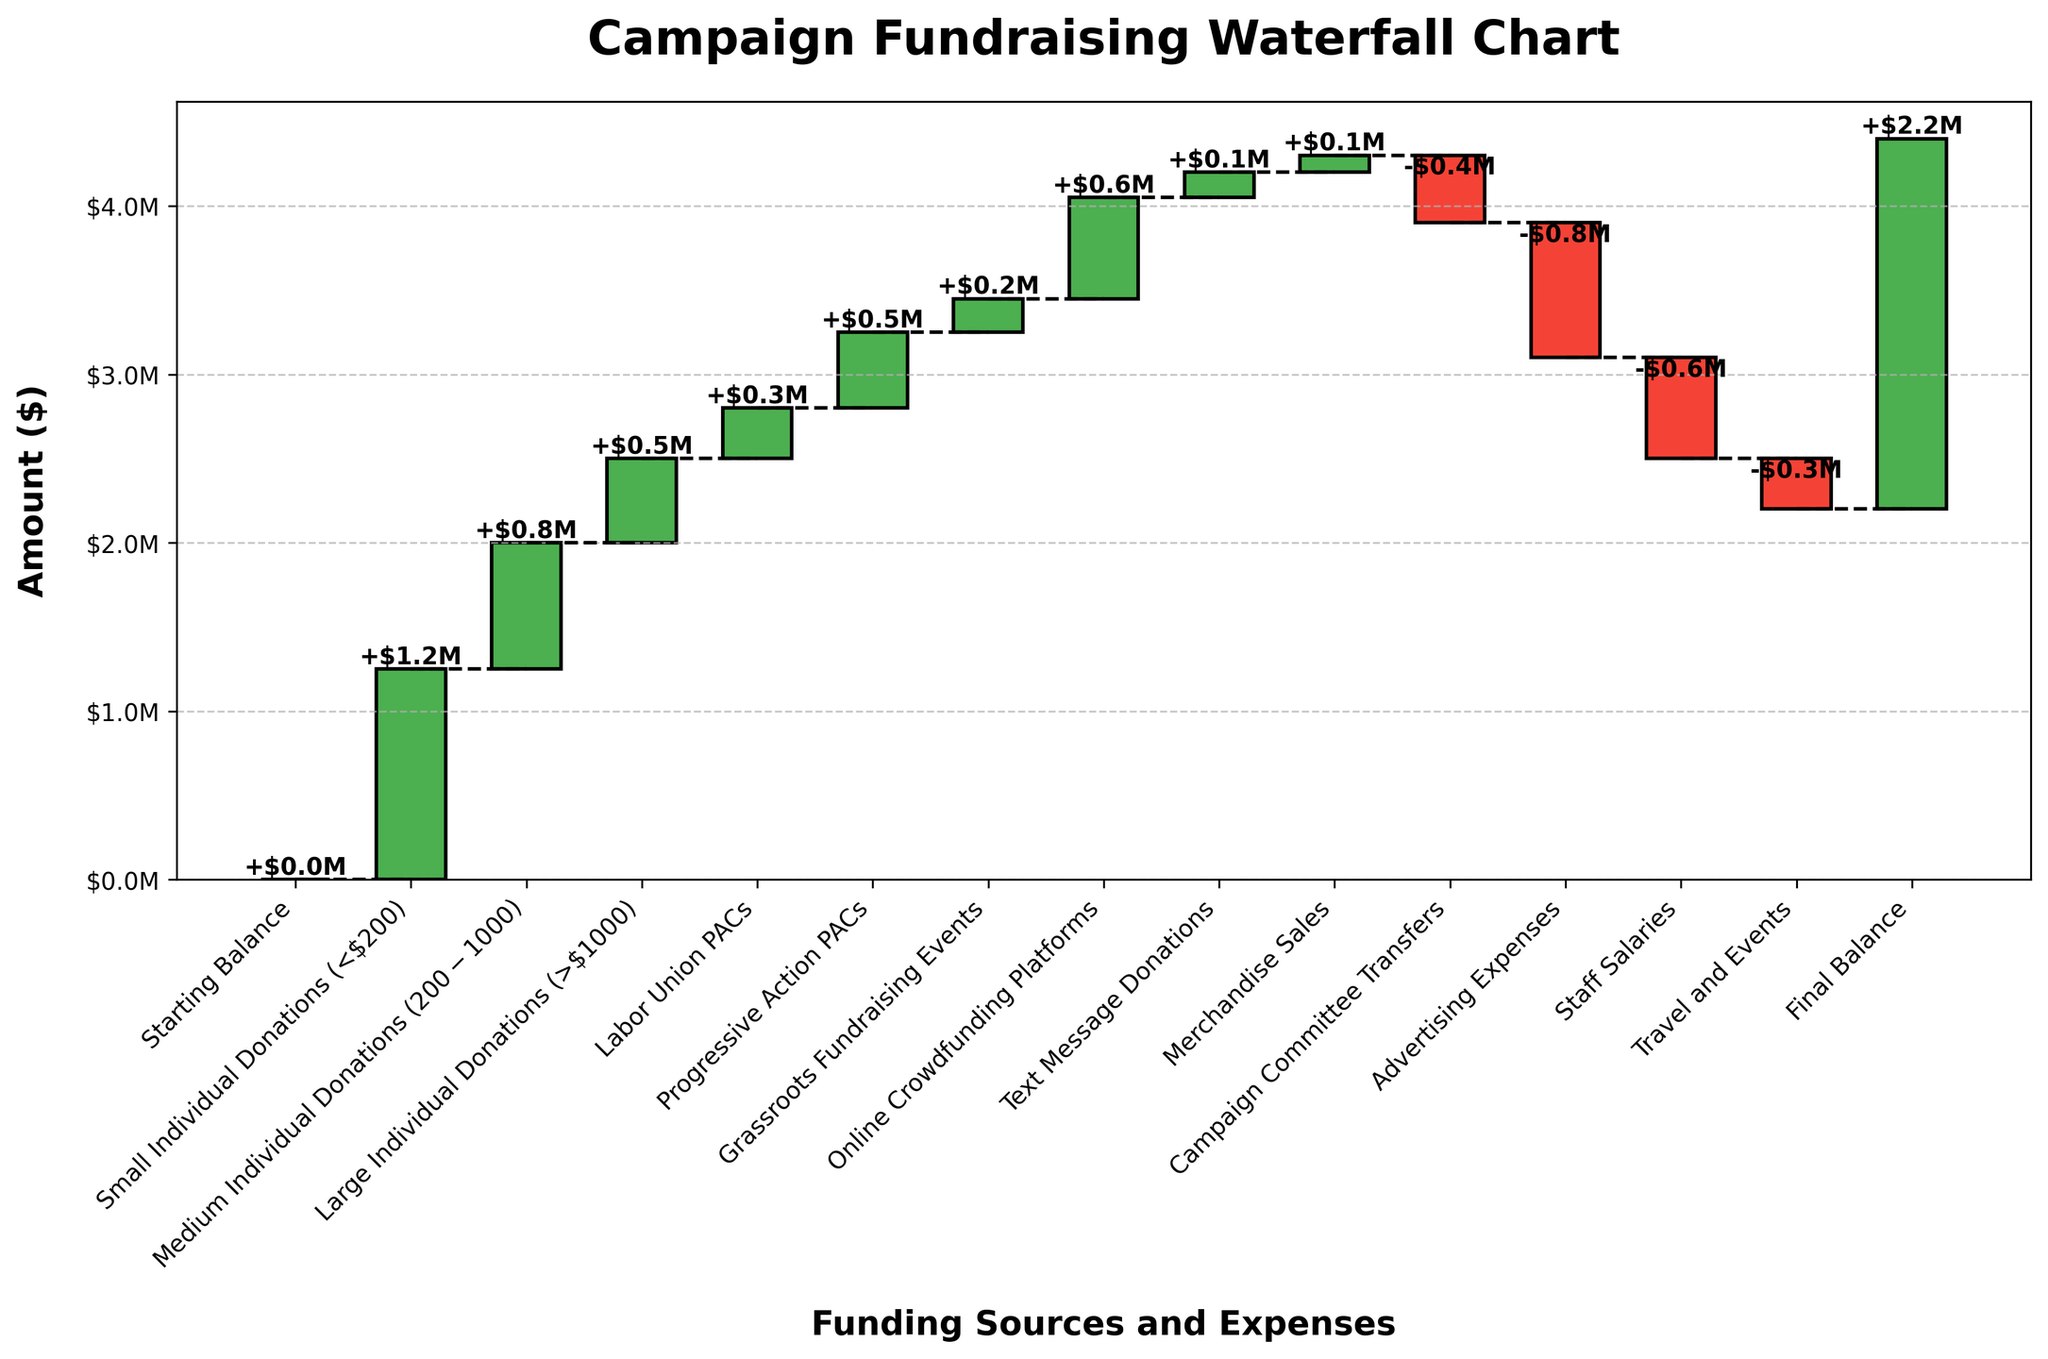What is the title of the chart? The title of the chart is given at the top, in a larger and bold font size compared to other text.
Answer: Campaign Fundraising Waterfall Chart What is the final balance of the campaign funds? The final balance is the last data point on the chart, indicated after all incomes and expenses.
Answer: $2.2M What does the color difference in the bars represent? The color difference in the bars typically indicates positive (green) and negative (red) values. Green bars are for incomes and red bars for expenses.
Answer: Positive and negative values Which category contributed the most to the campaign funds? The height of the bars represents the amount contributed or deducted in each category. The highest positive bar will indicate the largest contribution.
Answer: Small Individual Donations (<$200) How much more did 'Small Individual Donations' contribute compared to 'Large Individual Donations'? To find the difference, subtract the value of 'Large Individual Donations' from 'Small Individual Donations' (-$200,000).
Answer: $750,000 How much did Grassroots Fundraising Events and Online Crowdfunding Platforms together contribute? To find the total contribution from these two categories, sum their values together (200,000 + 600,000 = 800,000).
Answer: $800,000 Which expenses had the most significant negative impact on the campaign funds? The largest negative bar represents the expense with the highest deduction.
Answer: Advertising Expenses What is the combined total from all the positive contributions? Sum all the values from the categories contributing positively: 1,250,000 + 750,000 + 500,000 + 300,000 + 450,000 + 200,000 + 600,000 + 150,000 + 100,000 = 4,300,000.
Answer: $4.3M What is the difference between the campaign's total income and its total expenses? First, calculate the total income ($4,300,000), then the total expenses (-$2,100,000 from the combined negative values), and subtract expenses from income (4,300,000 - 2,100,000 = 2,200,000).
Answer: $2.2M How does 'Travel and Events' expenses compare to 'Staff Salaries'? Compare their values directly; 'Travel and Events' expenses are lower than 'Staff Salaries' (-300,000 vs -600,000).
Answer: Lower 